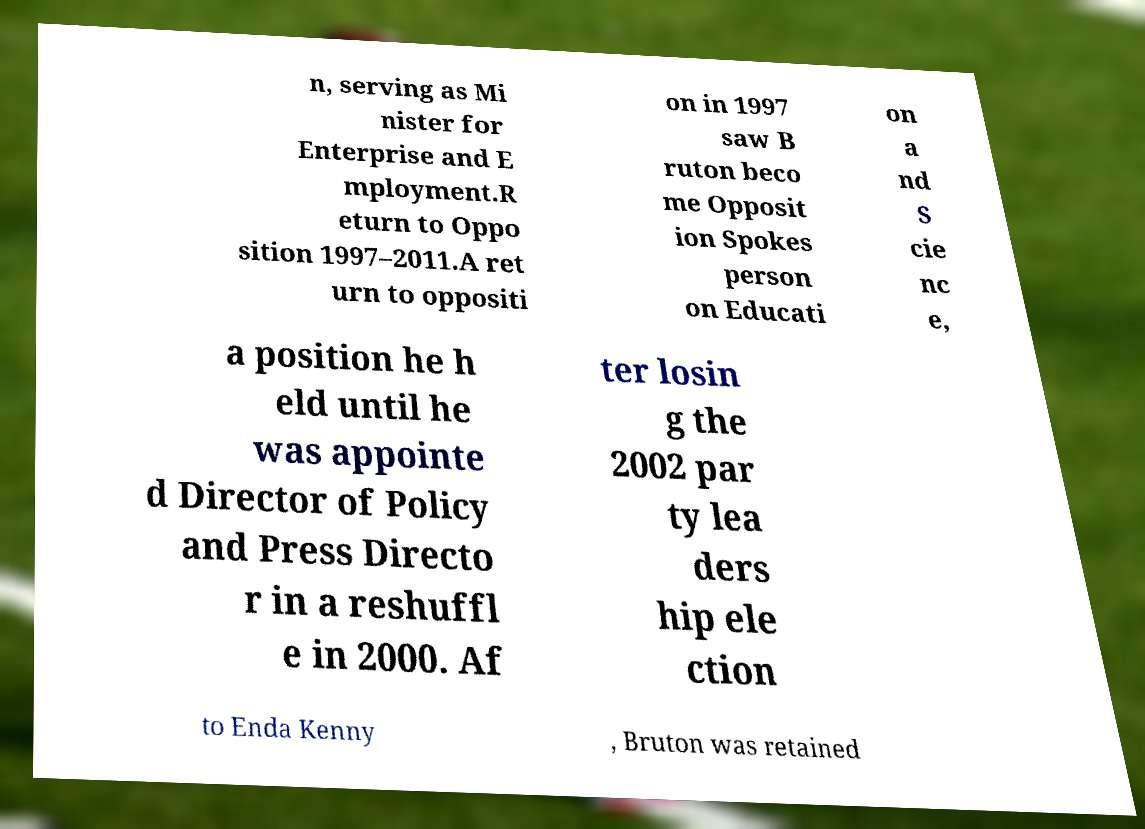I need the written content from this picture converted into text. Can you do that? n, serving as Mi nister for Enterprise and E mployment.R eturn to Oppo sition 1997–2011.A ret urn to oppositi on in 1997 saw B ruton beco me Opposit ion Spokes person on Educati on a nd S cie nc e, a position he h eld until he was appointe d Director of Policy and Press Directo r in a reshuffl e in 2000. Af ter losin g the 2002 par ty lea ders hip ele ction to Enda Kenny , Bruton was retained 